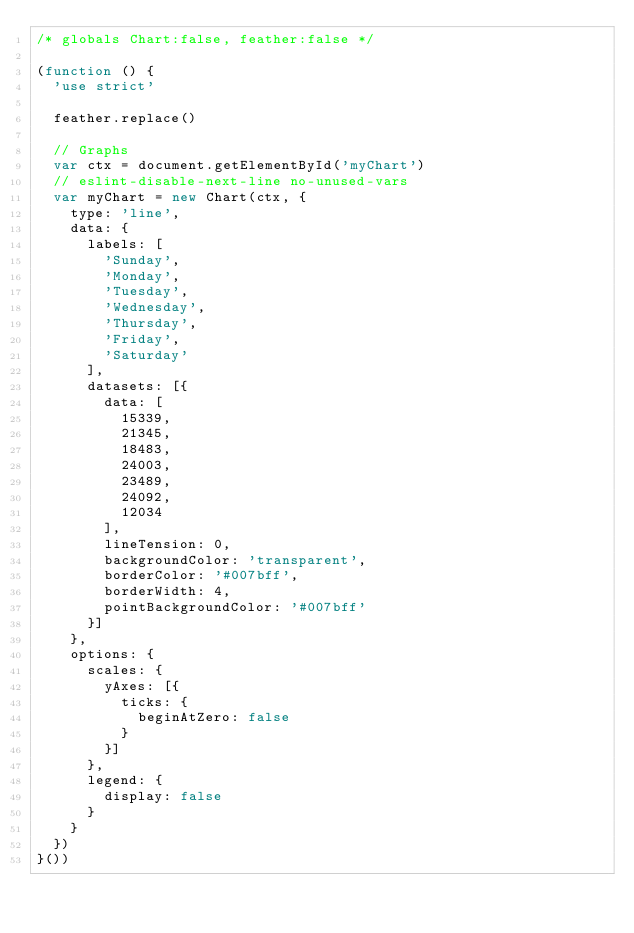Convert code to text. <code><loc_0><loc_0><loc_500><loc_500><_JavaScript_>/* globals Chart:false, feather:false */

(function () {
	'use strict'

	feather.replace()

	// Graphs
	var ctx = document.getElementById('myChart')
	// eslint-disable-next-line no-unused-vars
	var myChart = new Chart(ctx, {
		type: 'line',
		data: {
			labels: [
				'Sunday',
				'Monday',
				'Tuesday',
				'Wednesday',
				'Thursday',
				'Friday',
				'Saturday'
			],
			datasets: [{
				data: [
					15339,
					21345,
					18483,
					24003,
					23489,
					24092,
					12034
				],
				lineTension: 0,
				backgroundColor: 'transparent',
				borderColor: '#007bff',
				borderWidth: 4,
				pointBackgroundColor: '#007bff'
			}]
		},
		options: {
			scales: {
				yAxes: [{
					ticks: {
						beginAtZero: false
					}
				}]
			},
			legend: {
				display: false
			}
		}
	})
}())
</code> 